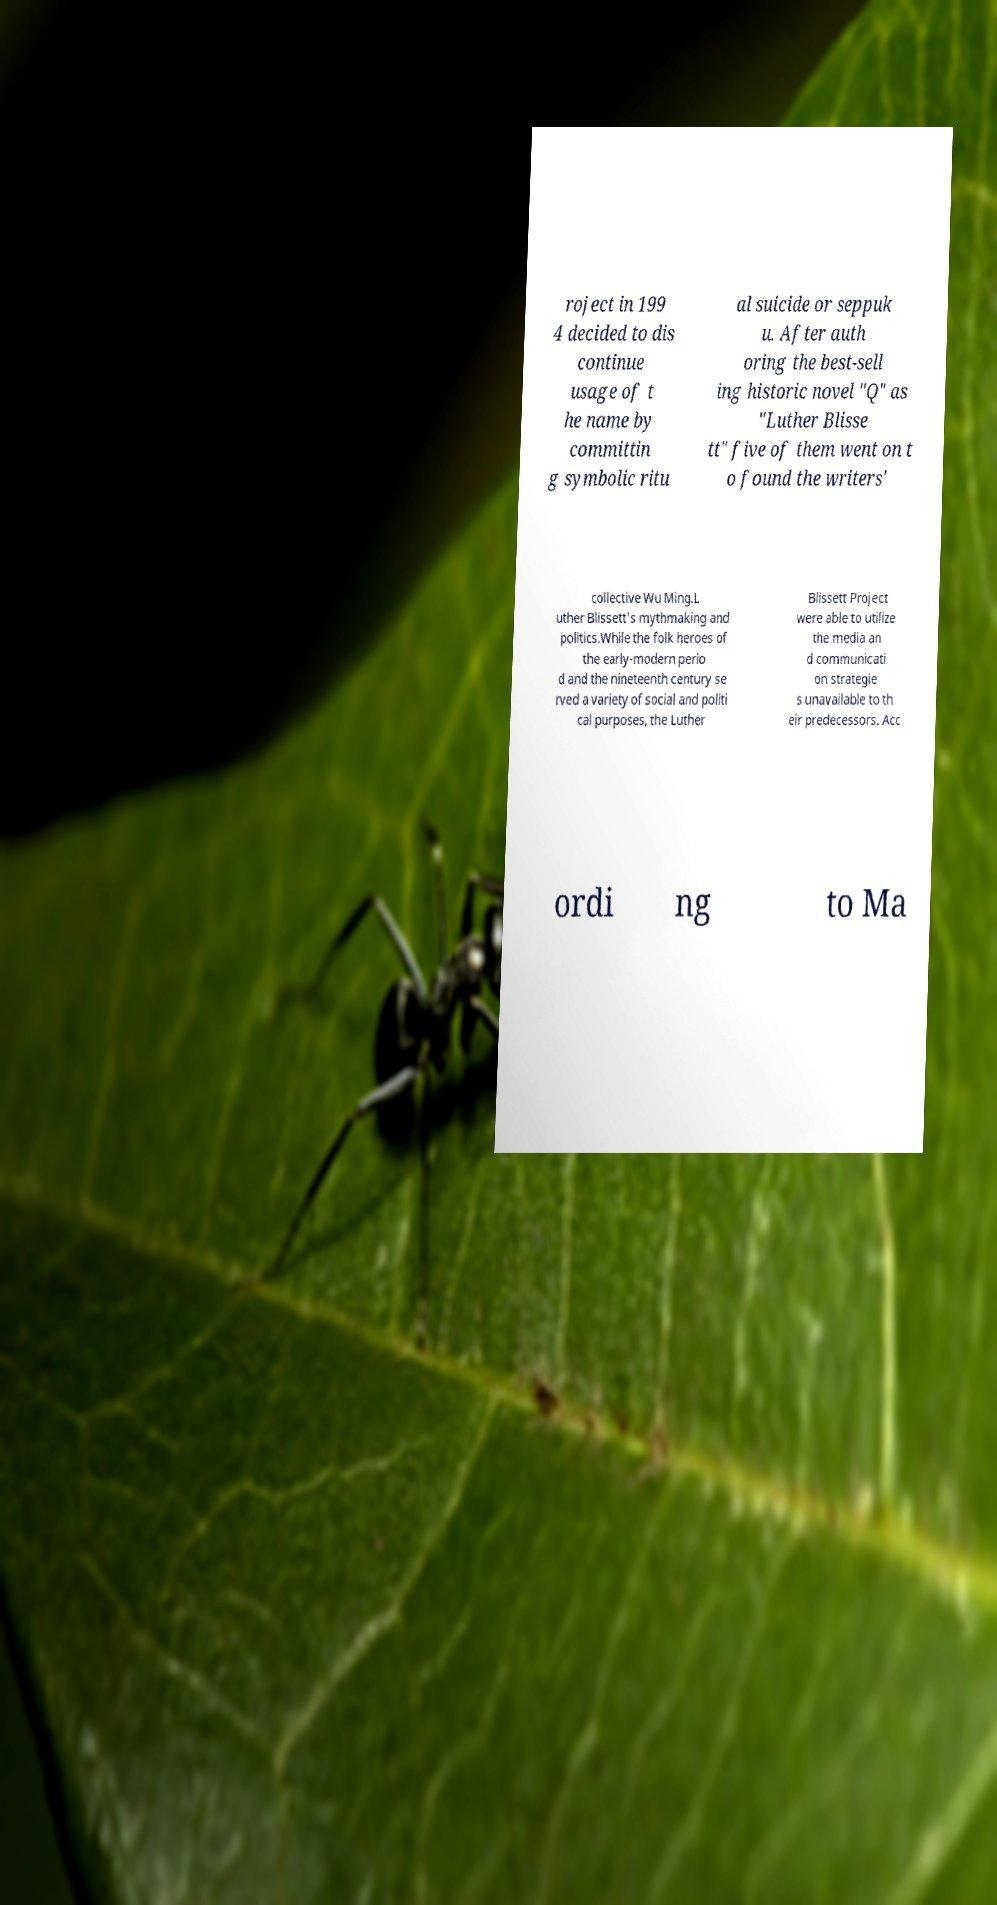Please identify and transcribe the text found in this image. roject in 199 4 decided to dis continue usage of t he name by committin g symbolic ritu al suicide or seppuk u. After auth oring the best-sell ing historic novel "Q" as "Luther Blisse tt" five of them went on t o found the writers' collective Wu Ming.L uther Blissett's mythmaking and politics.While the folk heroes of the early-modern perio d and the nineteenth century se rved a variety of social and politi cal purposes, the Luther Blissett Project were able to utilize the media an d communicati on strategie s unavailable to th eir predecessors. Acc ordi ng to Ma 